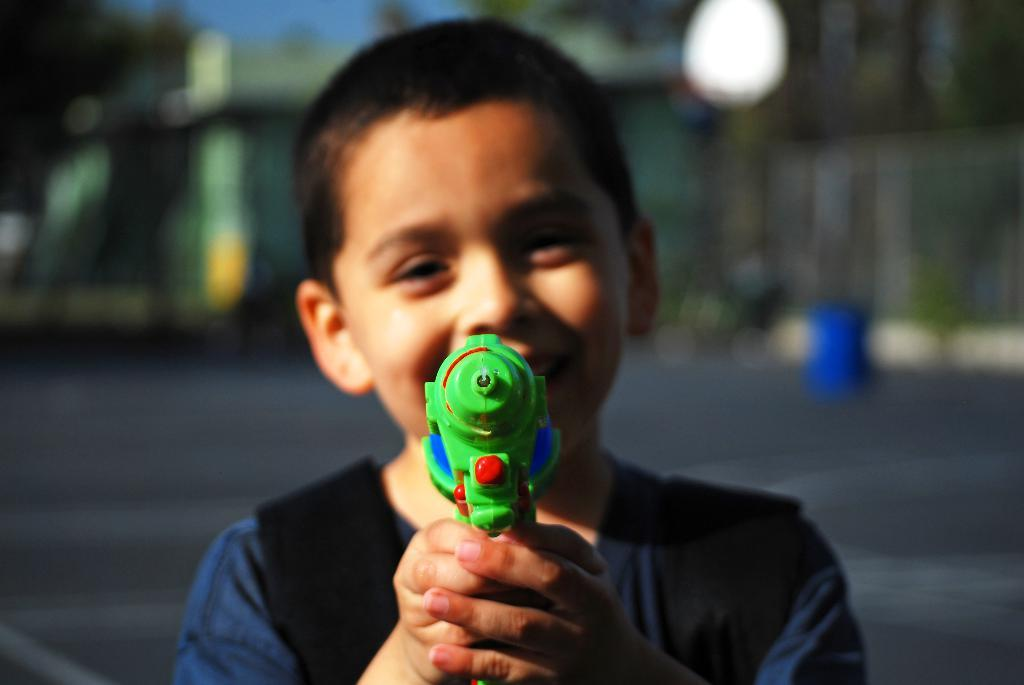Who is the main subject in the image? There is a boy in the image. What is the boy holding in his hands? The boy is holding a toy in his hands. What can be seen in the background of the image? There is a road, trees, and the sky visible in the background of the image. Can you hear the wind blowing in the image? There is no auditory information provided in the image, so it is not possible to determine if the wind is blowing or not. 